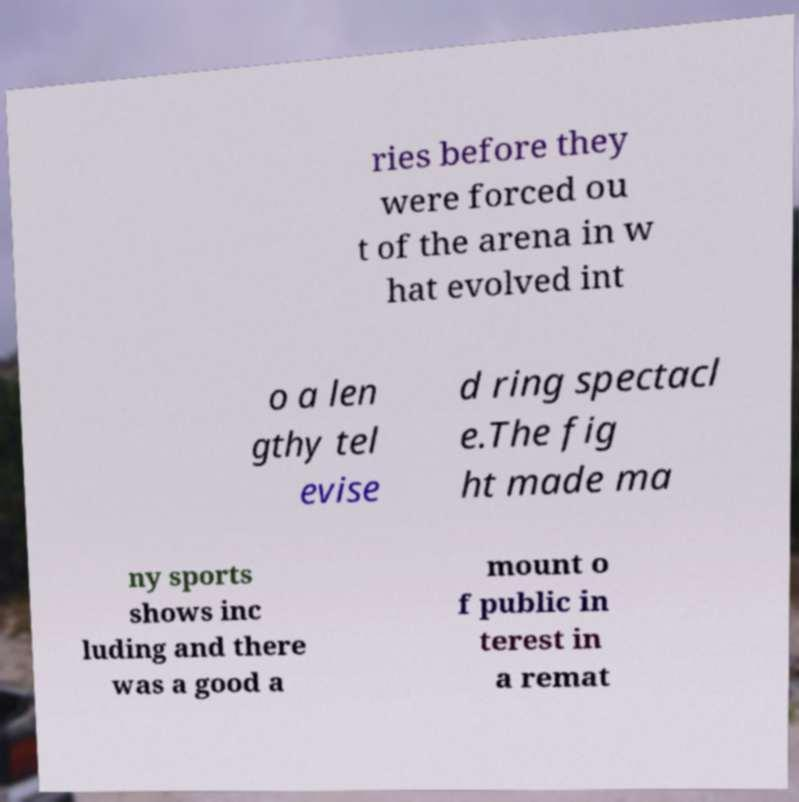Could you extract and type out the text from this image? ries before they were forced ou t of the arena in w hat evolved int o a len gthy tel evise d ring spectacl e.The fig ht made ma ny sports shows inc luding and there was a good a mount o f public in terest in a remat 